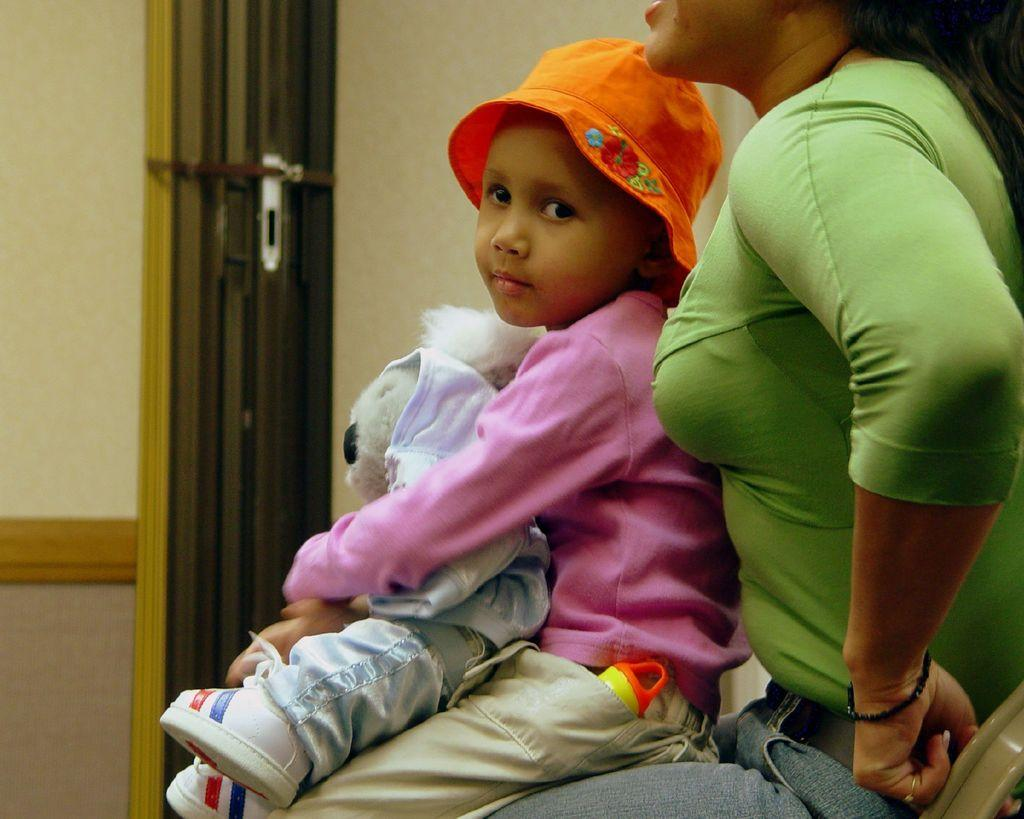What is the primary interaction between the girl and the woman in the image? The girl is sitting on the woman's lap. What object is being held by one of the girls in the image? There is another girl holding a teddy in the image. What type of tree is visible in the image? There is no tree present in the image. What map is being used by the girls in the image? There is no map present in the image. 